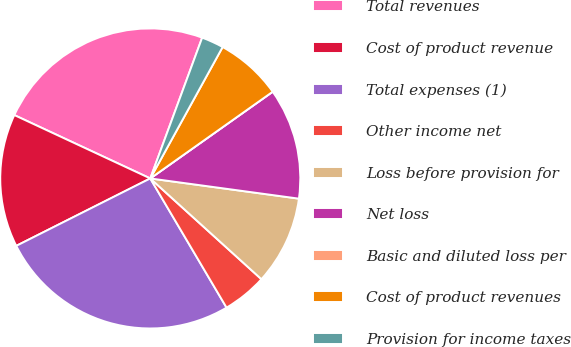Convert chart. <chart><loc_0><loc_0><loc_500><loc_500><pie_chart><fcel>Total revenues<fcel>Cost of product revenue<fcel>Total expenses (1)<fcel>Other income net<fcel>Loss before provision for<fcel>Net loss<fcel>Basic and diluted loss per<fcel>Cost of product revenues<fcel>Provision for income taxes<nl><fcel>23.68%<fcel>14.36%<fcel>26.07%<fcel>4.79%<fcel>9.57%<fcel>11.96%<fcel>0.0%<fcel>7.18%<fcel>2.39%<nl></chart> 